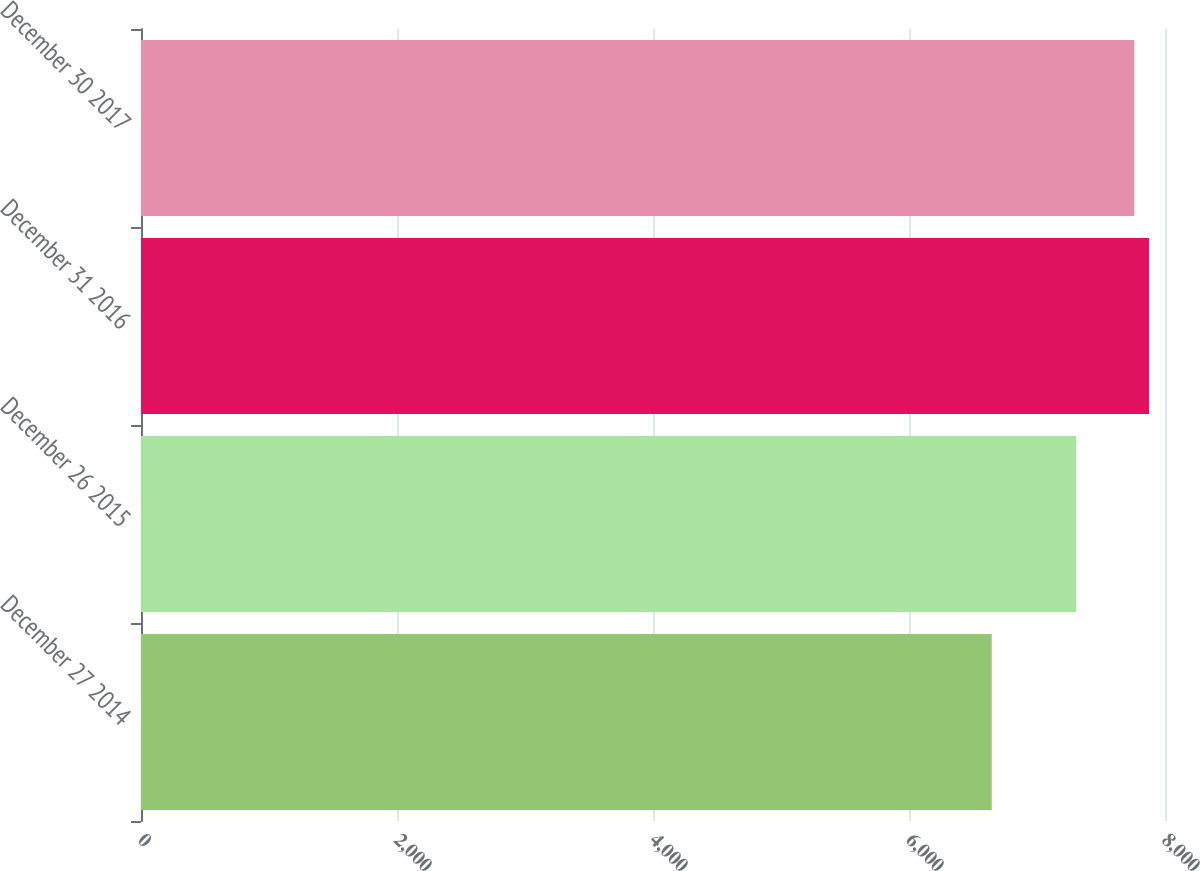Convert chart to OTSL. <chart><loc_0><loc_0><loc_500><loc_500><bar_chart><fcel>December 27 2014<fcel>December 26 2015<fcel>December 31 2016<fcel>December 30 2017<nl><fcel>6646<fcel>7306<fcel>7875.7<fcel>7760<nl></chart> 